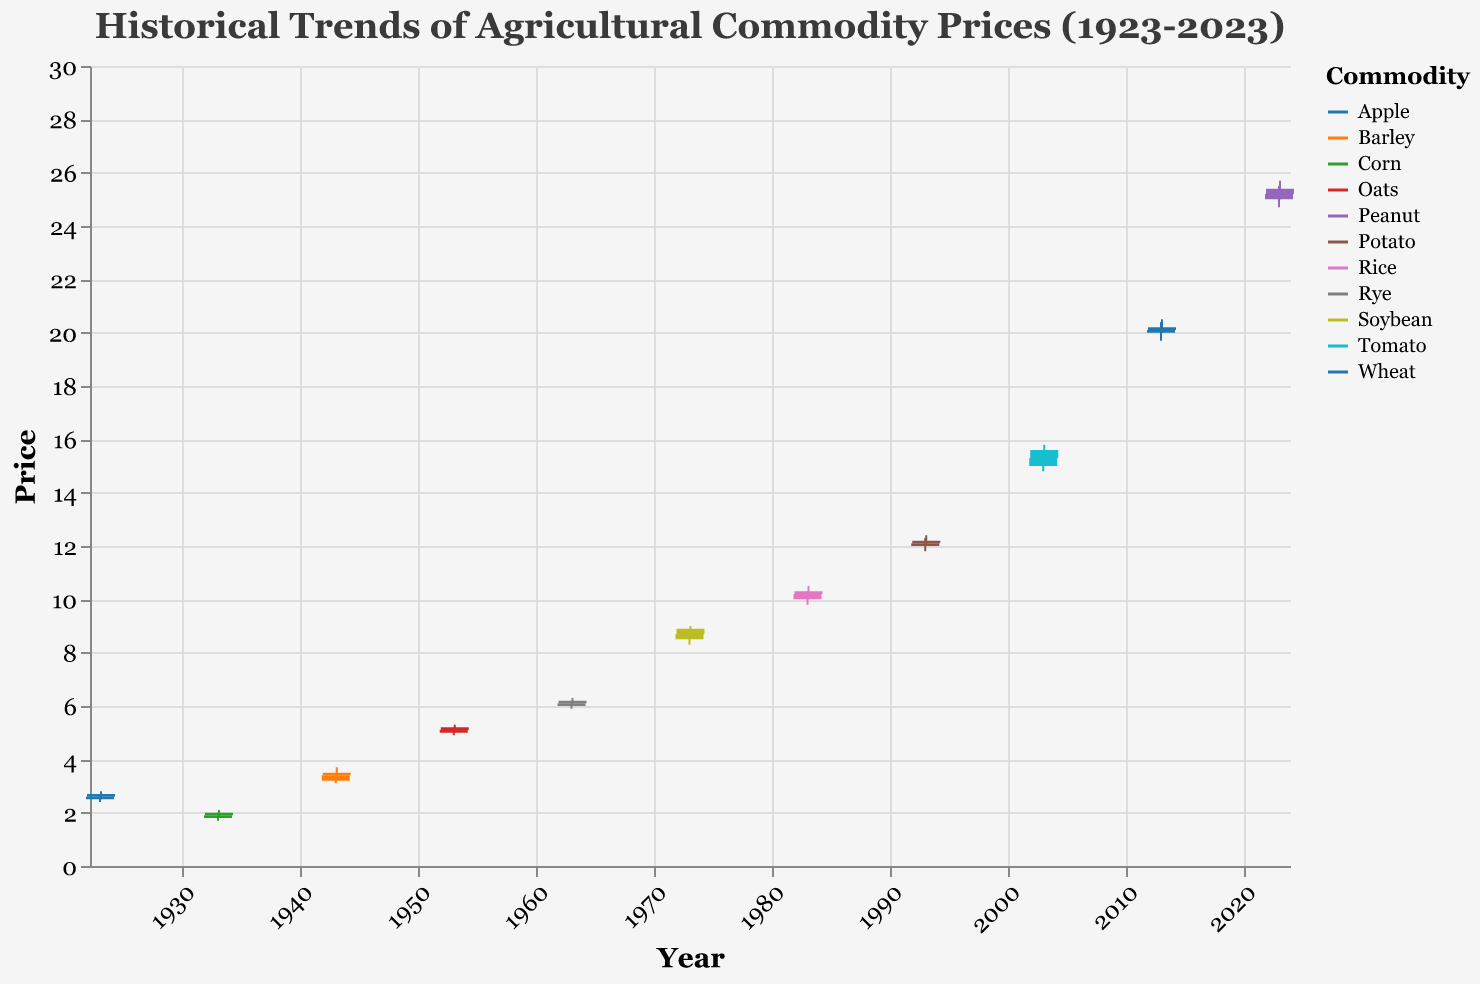What is the title of the figure? The title is displayed at the top of the figure, which reads "Historical Trends of Agricultural Commodity Prices (1923-2023)".
Answer: Historical Trends of Agricultural Commodity Prices (1923-2023) How many different commodities are represented in the figure? By looking at the color legend on the right side of the figure, we can count the number of unique commodities listed there.
Answer: 10 What is the price range of the Peanut commodity in January 2023? The 'Low' and 'High' prices for Peanut in January 2023 are indicated by the bottom and top points of the vertical line. The low is 24.70 and the high is 25.50.
Answer: 24.70 - 25.50 Which commodity had the highest closing price in the last century? First, identify the highest "Close" value by scanning vertically, then check which commodity is associated with that bar color. The highest closing price is 25.40, which corresponds to Peanut in February 2023.
Answer: Peanut What is the average closing price of Wheat? Calculate the average by adding the closing prices of Wheat and dividing by the number of data points available for Wheat: (2.60 + 2.70) / 2.
Answer: 2.65 Between which years did the commodity prices appear to rise substantially? We need to identify the time period where we see continuous vertical growth in the bar heights. Significant increases are noticed between 1973 and 1983.
Answer: 1973-1983 Which commodity had a higher opening price in February 1933, Corn or Wheat? Locate February 1933 and compare the opening prices for Corn and Wheat. Corn had an opening price of 1.90. Wheat data is not present for 1933.
Answer: Corn What is the price difference between the highest and lowest closing prices in the figure? Identify the highest closing price (Peanut in Feb 2023 at 25.40) and the lowest closing price (Corn in Jan 1933 at 1.90). Subtract the lowest from the highest: 25.40 - 1.90.
Answer: 23.50 Which commodity had a steadier price range (smaller difference between high and low) in January 2023? Compare the 'High' and 'Low' prices of each commodity in January 2023. Peanut's range is smaller (25.50 - 24.70) compared to other months.
Answer: Peanut 